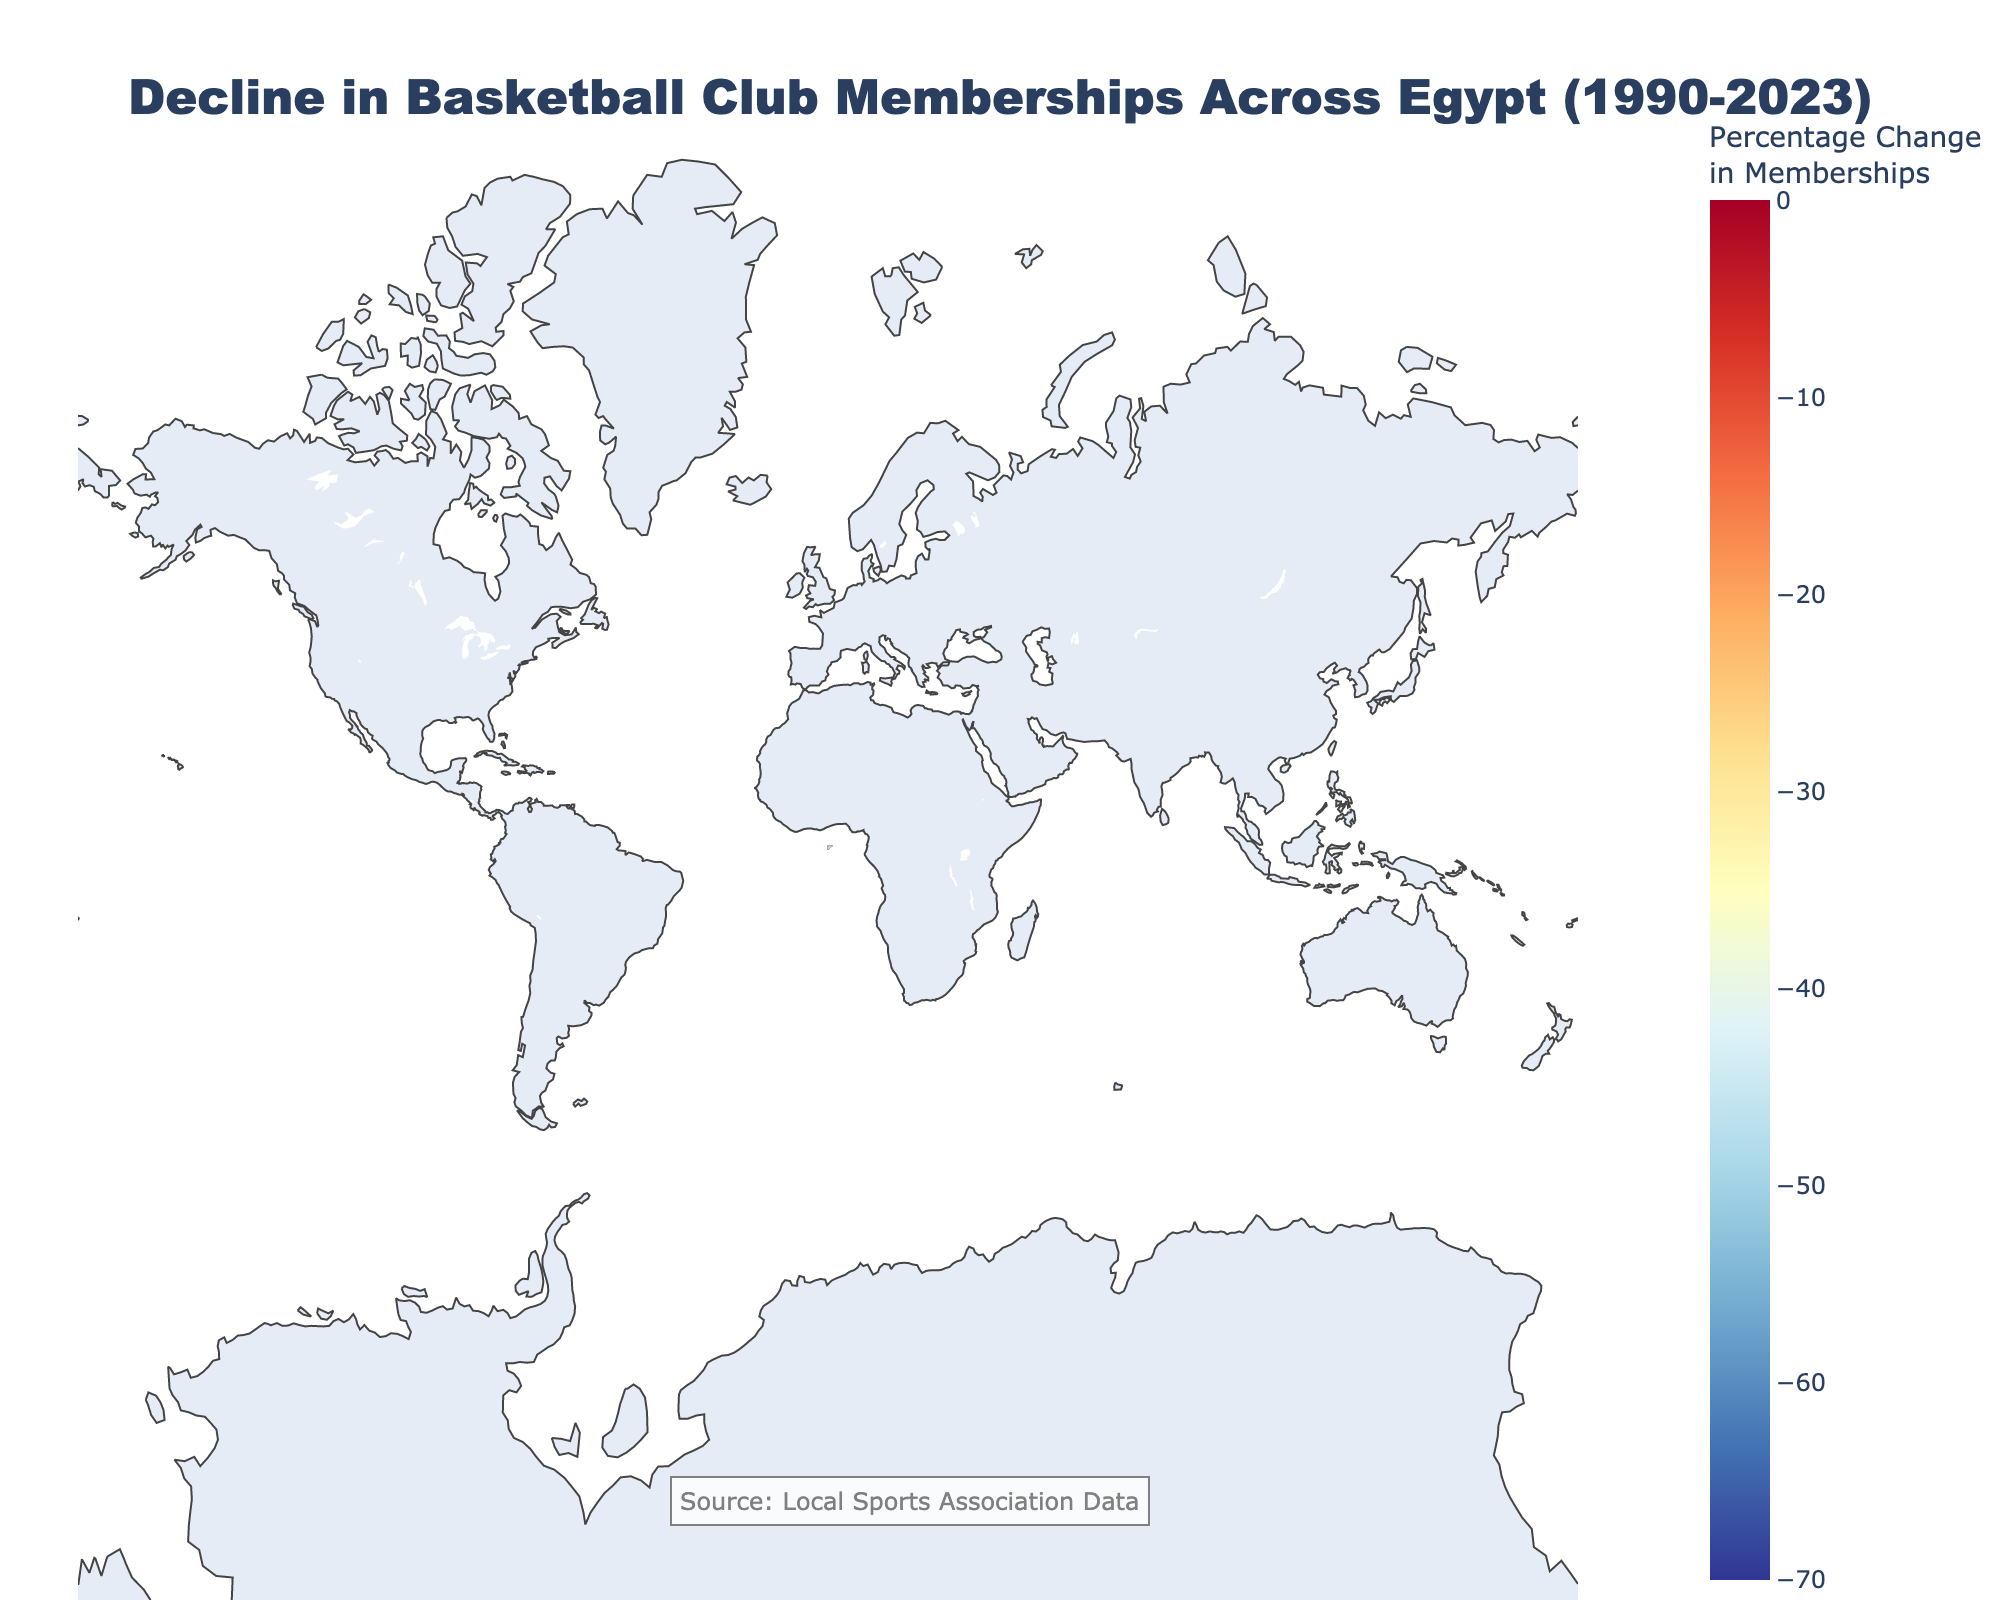What is the title of the plot? The title can be found at the top of the figure, providing a summary of the main topic.
Answer: Decline in Basketball Club Memberships Across Egypt (1990-2023) Which governorate has the least percentage decrease in basketball club memberships? Look for the area on the map with the lightest color, which corresponds to a smaller percentage decrease. Identify the governorate's name from the annotations.
Answer: Cairo Which governorate exhibits the highest percentage decline in memberships? Identify the area on the heatmap with the darkest color indicating the largest decline. Check the corresponding label to find the governorate's name.
Answer: Aswan What is the percentage change in memberships for Luxor? Locate Luxor on the map and refer to the corresponding annotation for the percentage change.
Answer: -48.6% Compare the membership change between Cairo and Alexandria. Which has a higher decline? Look for both Cairo and Alexandria on the heatmap, compare their annotations, and identify which has the higher percentage decline.
Answer: Alexandria What is the overall trend in basketball club memberships from 1990 to 2023? Look at the general color distribution on the map: dark colors indicate large declines, suggesting the overall membership trend.
Answer: Decline How many governorates experienced more than a 50% decline in memberships? Count the number of governorates with annotations indicating percentage changes of -50% or lower.
Answer: 11 Is the decline in memberships uniform across all governorates? Assess the variety of colors across the heatmap; uniformity would show similar colors across regions.
Answer: No Which three governorates show the least decline in basketball club memberships? Identify the three governorates with the lightest color shades and check their annotations for the least percentage decreases.
Answer: Cairo, Dakahlia, Port Said What can be inferred about the trend in sports interest in Egypt from the plot? Deduce from the widespread decline in memberships as indicated by the colors across almost all governorates.
Answer: General decline in interest 